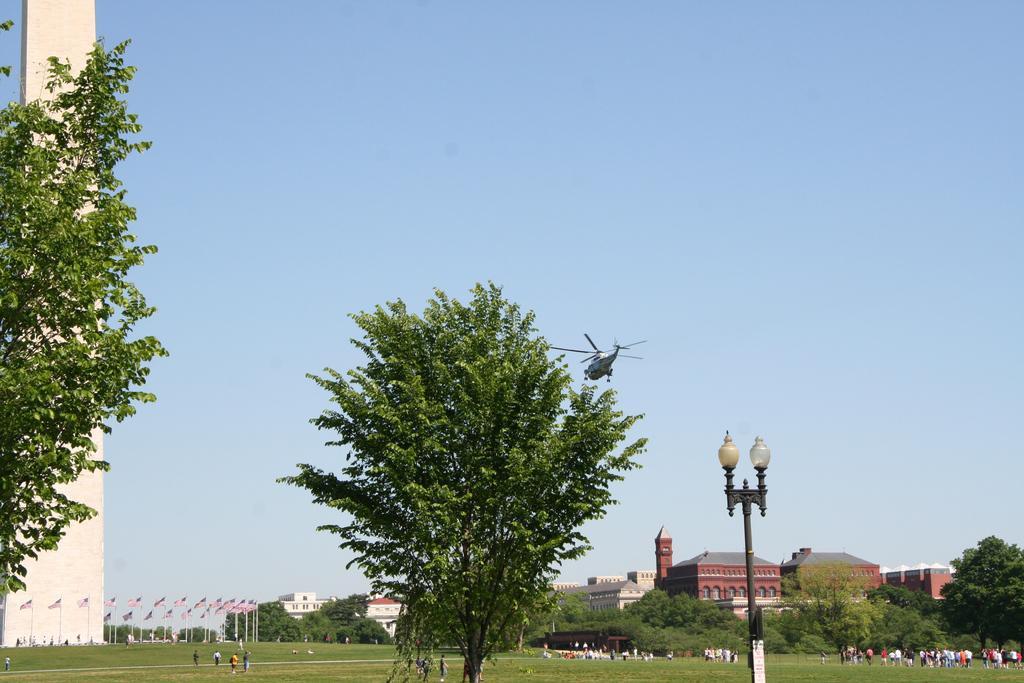In one or two sentences, can you explain what this image depicts? In this image we can see many buildings. There are many trees in the image. There is a grassy land in the image. There are many flags at the left side of the image. There are many people in the image. 